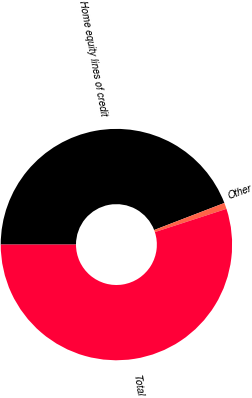<chart> <loc_0><loc_0><loc_500><loc_500><pie_chart><fcel>Home equity lines of credit<fcel>Other<fcel>Total<nl><fcel>44.14%<fcel>0.86%<fcel>54.99%<nl></chart> 